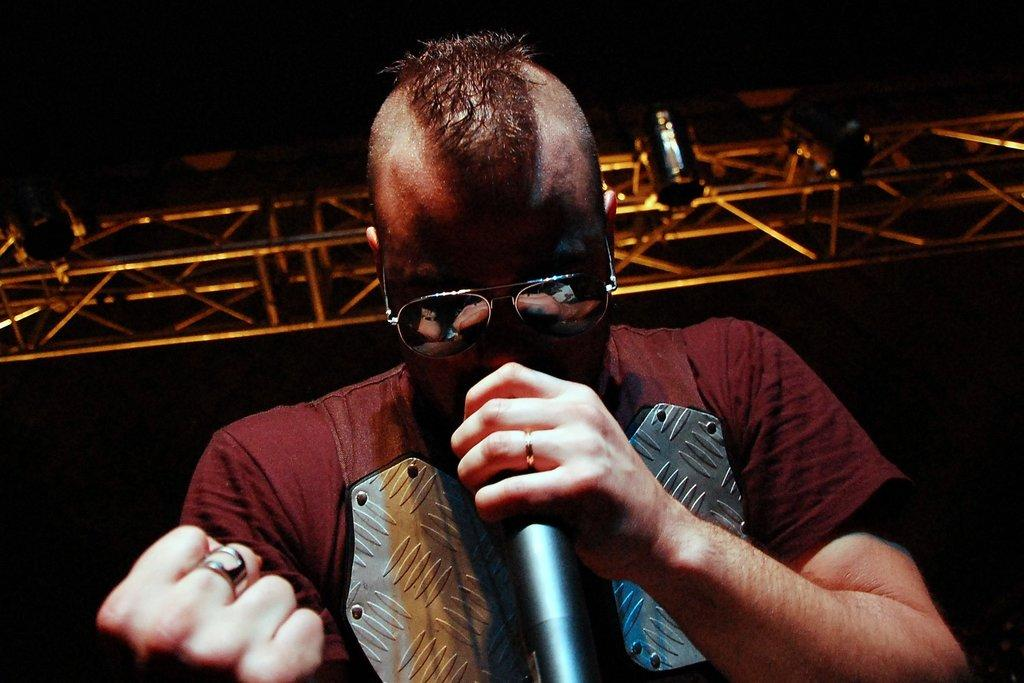What is the main subject of the image? The main subject of the image is a man. What is the man doing in the image? The man is standing and singing in the image. What is the man holding in his hand? The man is holding a microphone in his hand. What can be seen on the man's face? The man is wearing glasses. What is visible above the man in the image? There is a light visible above the man. What type of wool is being used to create the gate in the image? There is no wool or gate present in the image; it features a man singing while holding a microphone. What is the limit of the man's vocal range in the image? The image does not provide information about the man's vocal range or any limits associated with it. 